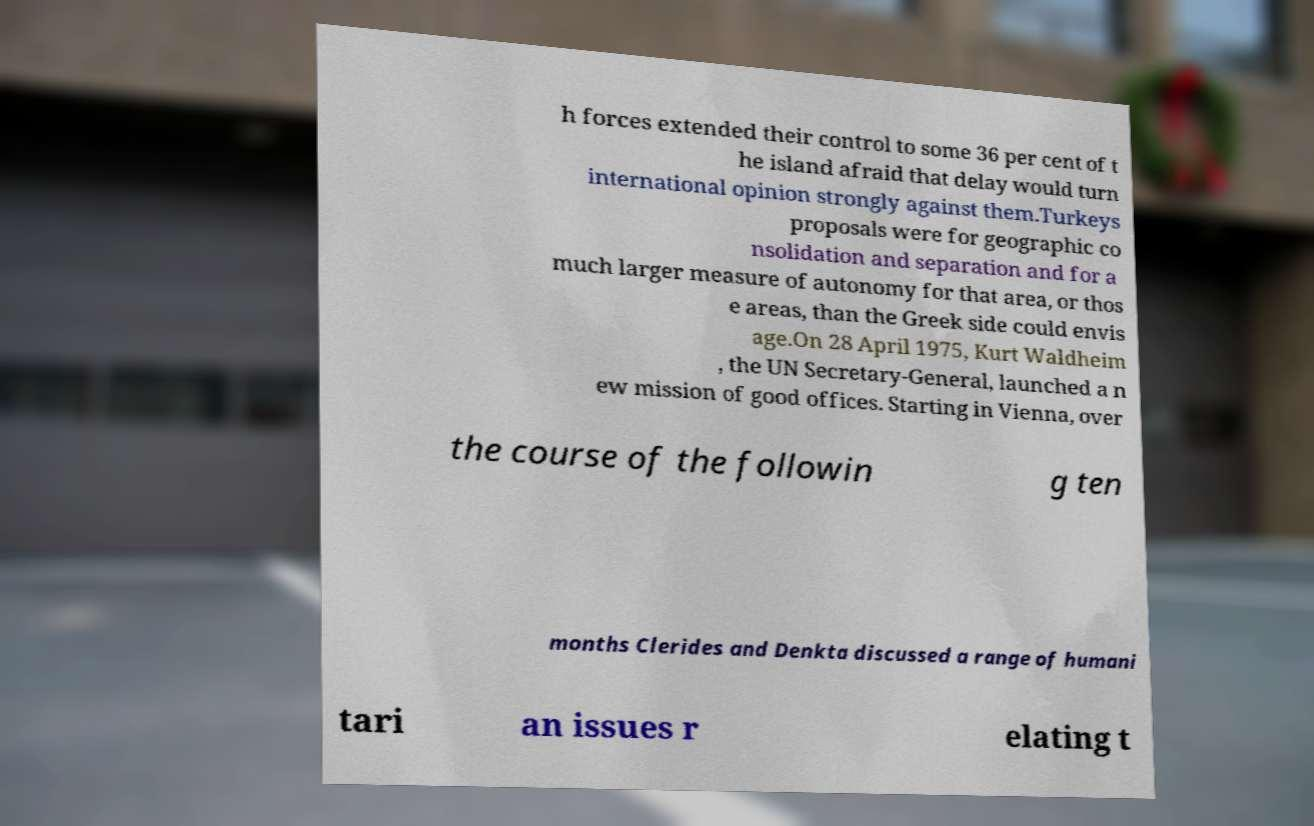Please identify and transcribe the text found in this image. h forces extended their control to some 36 per cent of t he island afraid that delay would turn international opinion strongly against them.Turkeys proposals were for geographic co nsolidation and separation and for a much larger measure of autonomy for that area, or thos e areas, than the Greek side could envis age.On 28 April 1975, Kurt Waldheim , the UN Secretary-General, launched a n ew mission of good offices. Starting in Vienna, over the course of the followin g ten months Clerides and Denkta discussed a range of humani tari an issues r elating t 